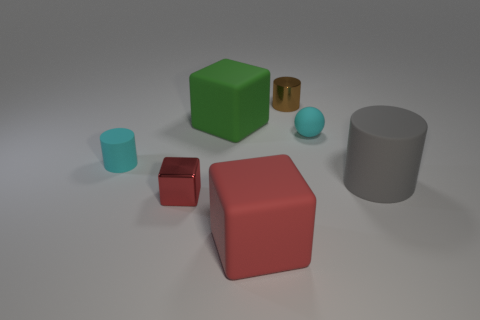What number of things are large purple metal spheres or cyan matte cylinders?
Provide a short and direct response. 1. There is a big cylinder that is made of the same material as the sphere; what color is it?
Give a very brief answer. Gray. There is a tiny matte thing that is right of the small cyan cylinder; is its shape the same as the small red object?
Provide a succinct answer. No. What number of things are either tiny cyan rubber spheres to the left of the large cylinder or small cyan things left of the large green object?
Your answer should be compact. 2. The other large thing that is the same shape as the big green rubber thing is what color?
Your answer should be very brief. Red. Is there anything else that has the same shape as the green matte object?
Ensure brevity in your answer.  Yes. There is a big red matte object; is its shape the same as the large thing that is right of the tiny ball?
Your response must be concise. No. What is the gray thing made of?
Offer a very short reply. Rubber. What size is the other matte thing that is the same shape as the large green rubber thing?
Keep it short and to the point. Large. What number of other things are the same material as the big gray thing?
Your answer should be very brief. 4. 